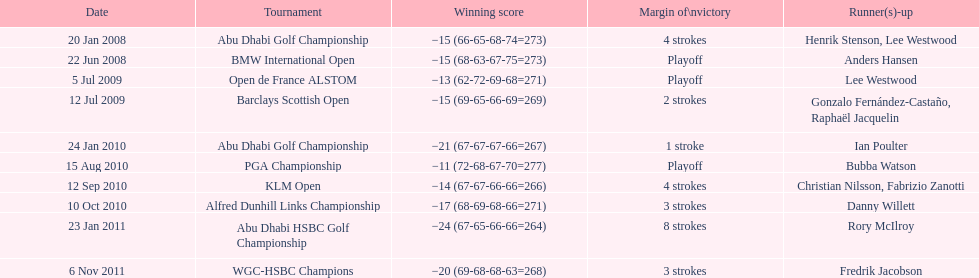What is the disparity in the number of strokes in the klm open and the barclays scottish open? 2 strokes. 